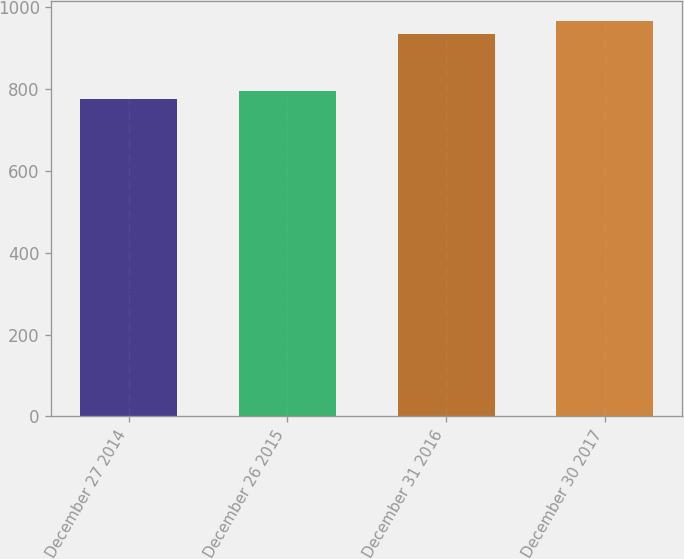Convert chart. <chart><loc_0><loc_0><loc_500><loc_500><bar_chart><fcel>December 27 2014<fcel>December 26 2015<fcel>December 31 2016<fcel>December 30 2017<nl><fcel>776<fcel>795.1<fcel>935<fcel>967<nl></chart> 